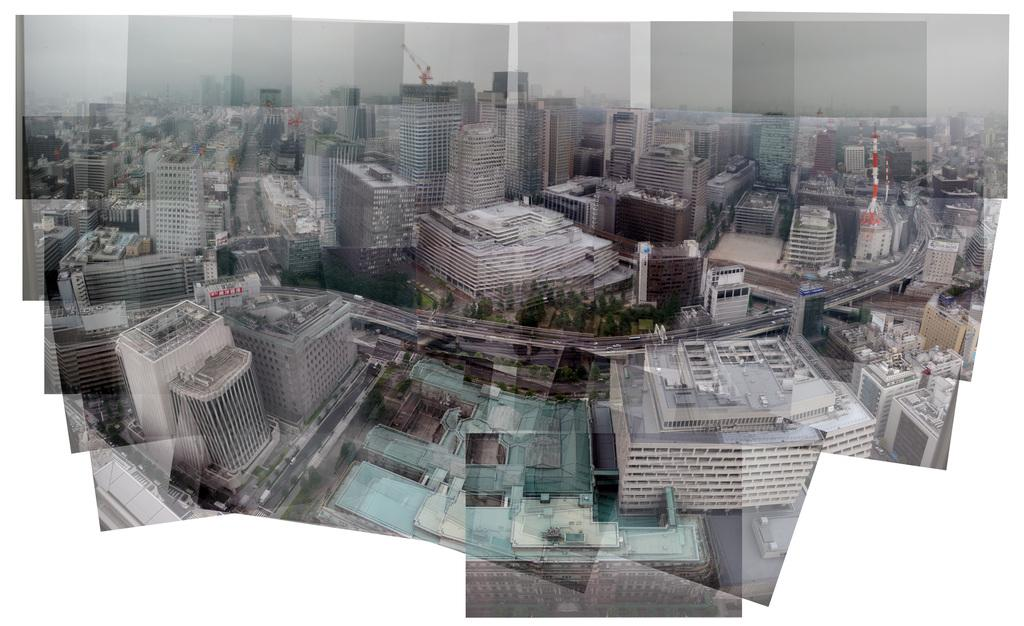What is the overall subject of the image? The image provides a complete view of a city. What are some of the prominent features of the city? There are tall buildings in the image. How are the buildings connected? Roads are visible in the image, connecting the buildings. What type of transportation can be seen in the image? Vehicles are present in the image. Where is the garden located in the image? There is no garden present in the image; it is a view of a city with tall buildings, roads, and vehicles. Can you describe the woman's hairstyle in the image? There is no woman present in the image; it is a view of a city with tall buildings, roads, and vehicles. 